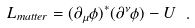<formula> <loc_0><loc_0><loc_500><loc_500>L _ { m a t t e r } = ( \partial _ { \mu } \phi ) ^ { \ast } ( \partial ^ { \nu } \phi ) - U \ .</formula> 